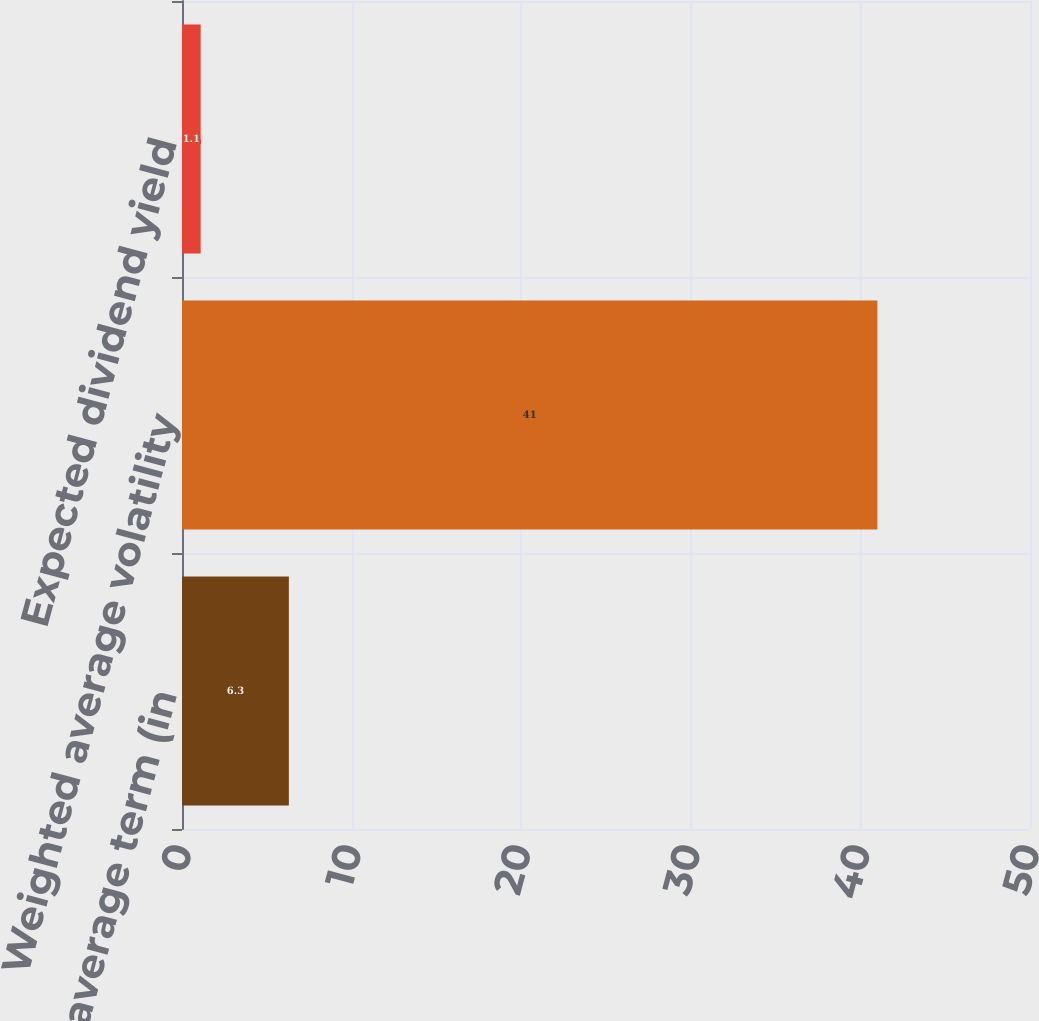<chart> <loc_0><loc_0><loc_500><loc_500><bar_chart><fcel>Expected average term (in<fcel>Weighted average volatility<fcel>Expected dividend yield<nl><fcel>6.3<fcel>41<fcel>1.1<nl></chart> 